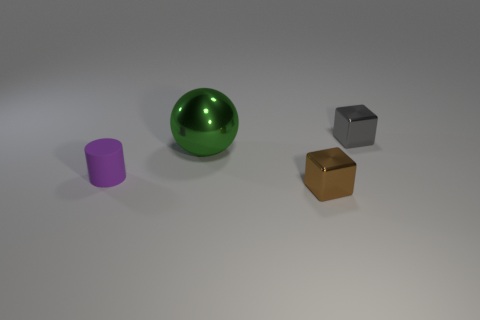Add 2 small gray shiny blocks. How many objects exist? 6 Subtract all spheres. How many objects are left? 3 Subtract all small blue matte balls. Subtract all green shiny things. How many objects are left? 3 Add 3 tiny gray metal cubes. How many tiny gray metal cubes are left? 4 Add 2 shiny things. How many shiny things exist? 5 Subtract 0 red balls. How many objects are left? 4 